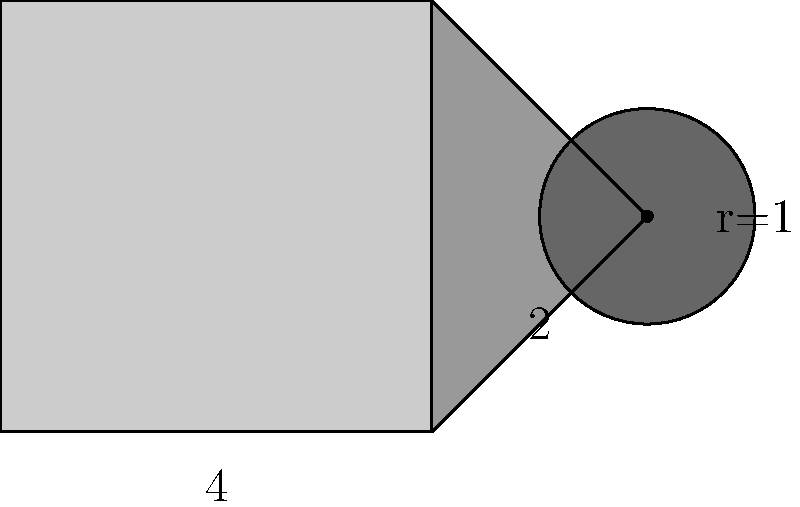You're designing a pixel art logo for a collaborative project. The logo consists of a square, a right triangle, and a circle, as shown in the diagram. The square has a side length of 4 units, the triangle has a base of 2 units and a height of 4 units, and the circle has a radius of 1 unit. Calculate the total perimeter and area of the logo. Let's break this down step-by-step:

1. Perimeter calculation:
   a. Square: $4 * 4 = 16$ units
   b. Triangle: $2 + 4 + \sqrt{2^2 + 4^2} = 2 + 4 + \sqrt{20} \approx 10.47$ units
   c. Circle: $2\pi r = 2\pi * 1 = 2\pi \approx 6.28$ units
   Total perimeter: $16 + 10.47 + 6.28 \approx 32.75$ units

2. Area calculation:
   a. Square: $4 * 4 = 16$ square units
   b. Triangle: $\frac{1}{2} * 2 * 4 = 4$ square units
   c. Circle: $\pi r^2 = \pi * 1^2 = \pi \approx 3.14$ square units
   Total area: $16 + 4 + 3.14 = 23.14$ square units

Therefore, the total perimeter is approximately 32.75 units, and the total area is approximately 23.14 square units.
Answer: Perimeter: $\approx 32.75$ units; Area: $\approx 23.14$ square units 